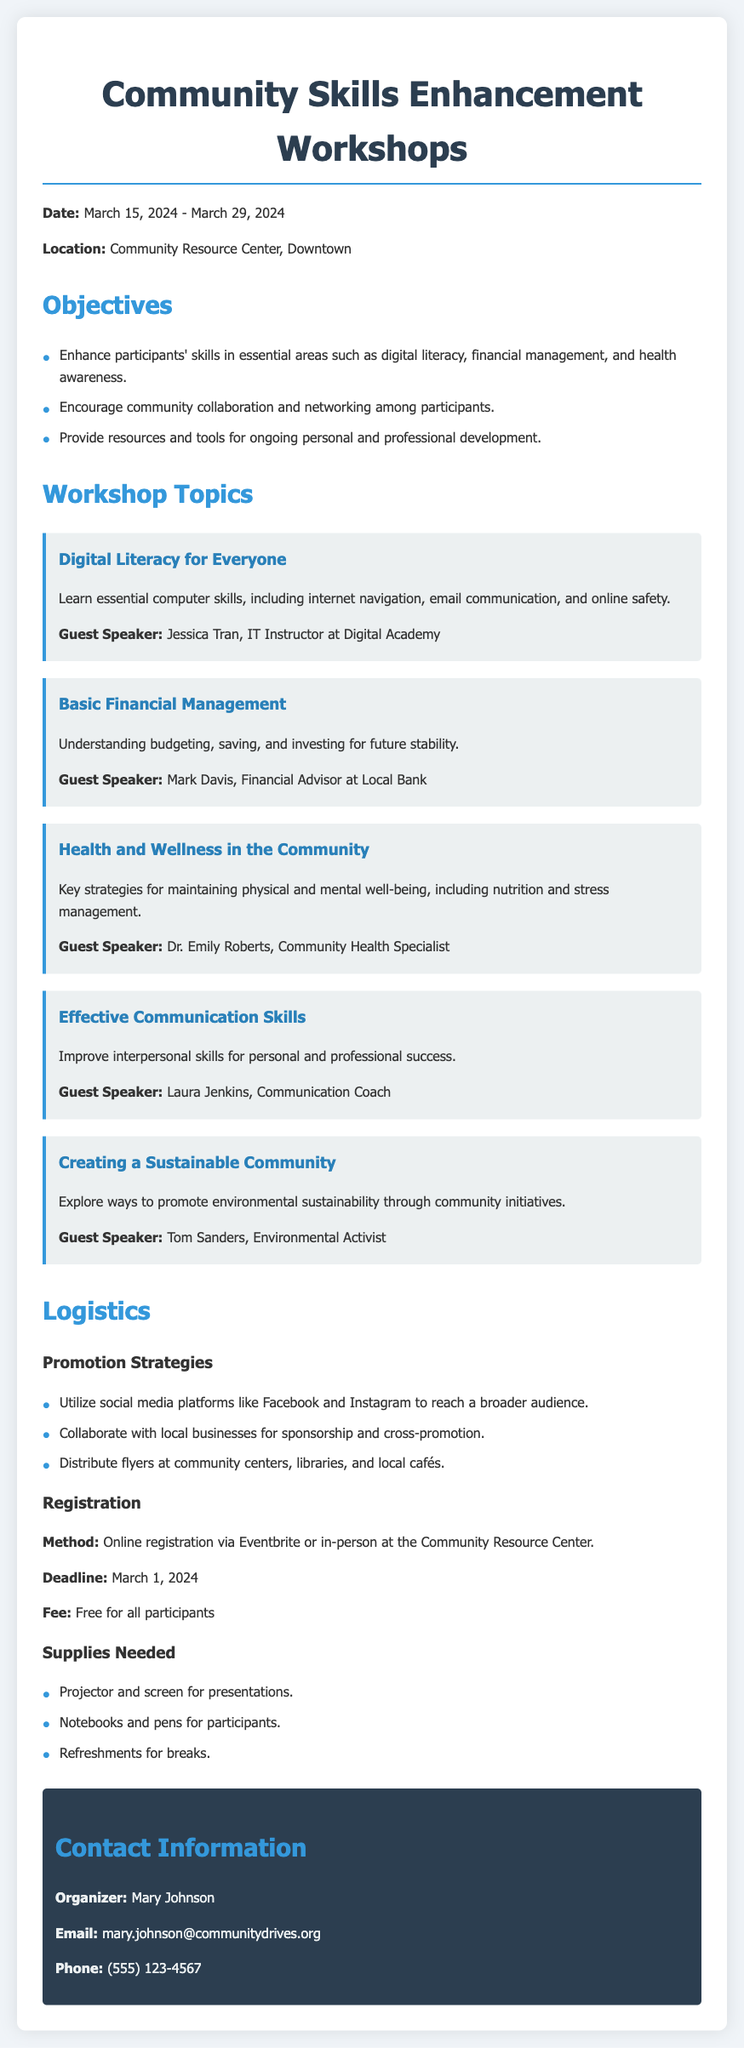what are the workshop dates? The workshop dates are from March 15, 2024, to March 29, 2024.
Answer: March 15, 2024 - March 29, 2024 where will the workshops be held? The location for the workshops is mentioned in the document.
Answer: Community Resource Center, Downtown who is the guest speaker for the Digital Literacy workshop? The document lists Jessica Tran as the guest speaker for this workshop.
Answer: Jessica Tran what is the fee for participants? The document states the fee for the workshops.
Answer: Free for all participants what is one of the objectives of the workshops? The document lists several objectives; one of them is mentioned here.
Answer: Enhance participants' skills in essential areas such as digital literacy, financial management, and health awareness how will the workshops be promoted? The document outlines promotion strategies, including different platforms.
Answer: Utilize social media platforms like Facebook and Instagram when is the registration deadline? The registration deadline is explicitly mentioned in the document.
Answer: March 1, 2024 what supplies are needed for the workshops? The document specifies several supplies that will be needed.
Answer: Projector and screen for presentations who is the contact person for more information? The organizer's name is provided in the contact information section.
Answer: Mary Johnson 